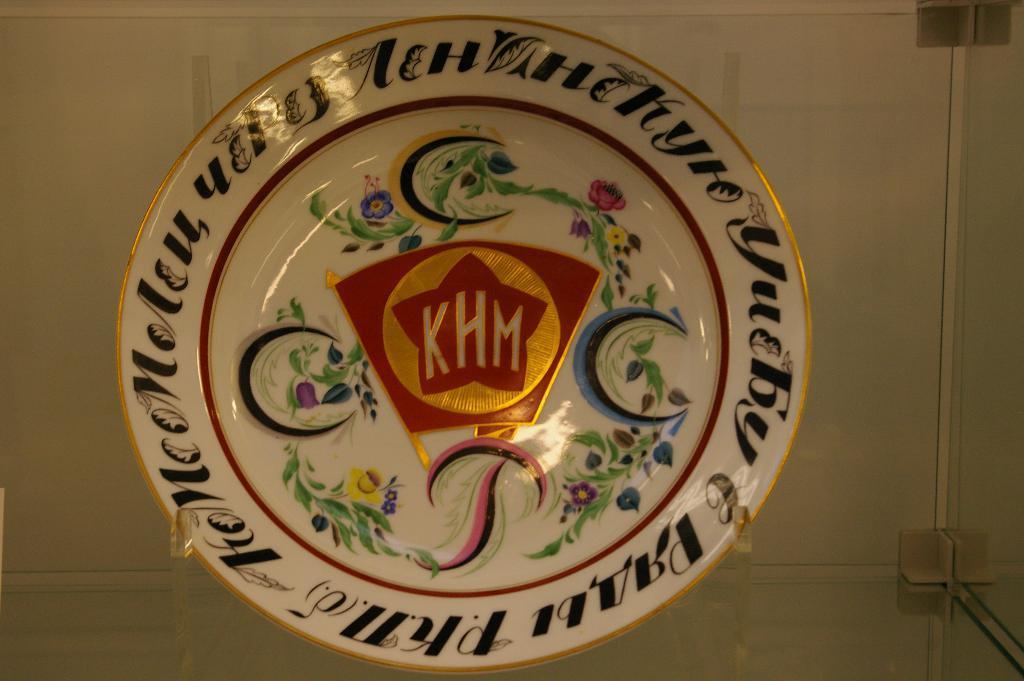Could you give a brief overview of what you see in this image? In this picture we can see a glass rack. We can see a designed plate with some text and painting. It is placed on a stand. 